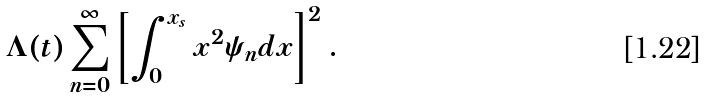Convert formula to latex. <formula><loc_0><loc_0><loc_500><loc_500>\Lambda ( t ) \sum _ { n = 0 } ^ { \infty } \left [ \int _ { 0 } ^ { x _ { s } } x ^ { 2 } \psi _ { n } d x \right ] ^ { 2 } .</formula> 